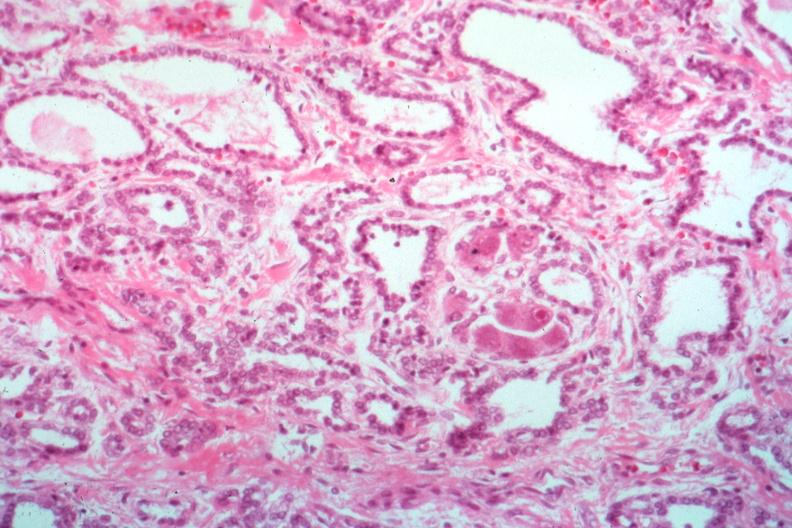s beckwith-wiedemann syndrome present?
Answer the question using a single word or phrase. No 